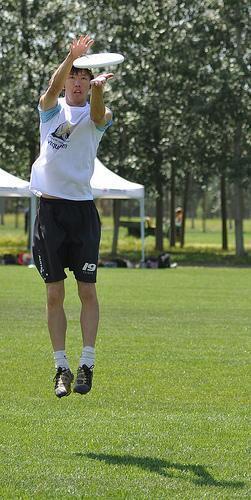How many hands is the man using to catch the Frisbee?
Give a very brief answer. 2. 